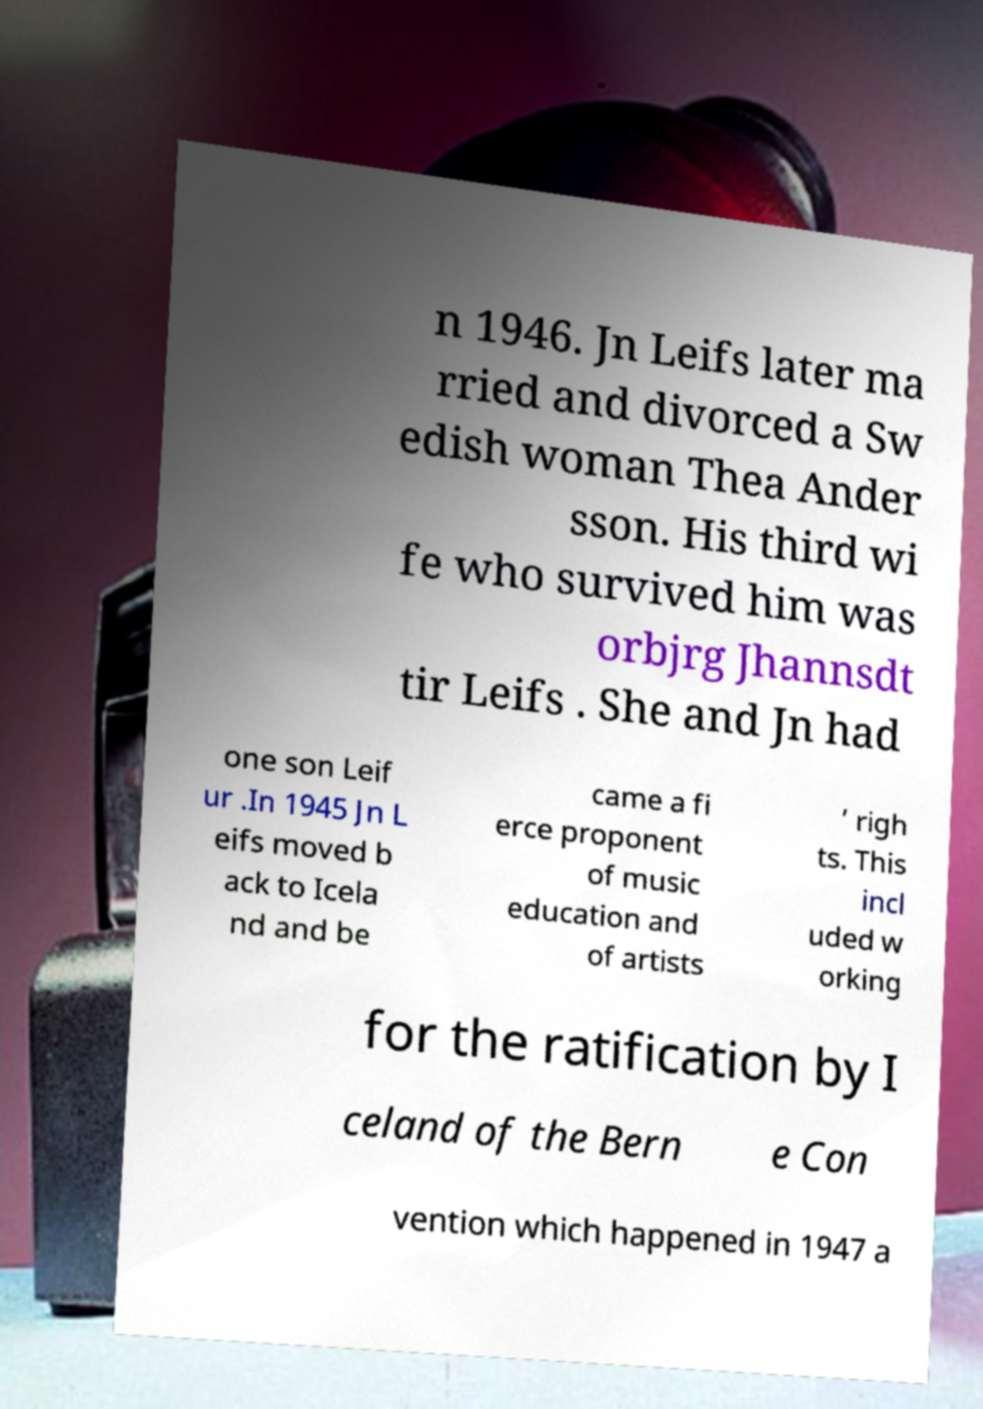There's text embedded in this image that I need extracted. Can you transcribe it verbatim? n 1946. Jn Leifs later ma rried and divorced a Sw edish woman Thea Ander sson. His third wi fe who survived him was orbjrg Jhannsdt tir Leifs . She and Jn had one son Leif ur .In 1945 Jn L eifs moved b ack to Icela nd and be came a fi erce proponent of music education and of artists ’ righ ts. This incl uded w orking for the ratification by I celand of the Bern e Con vention which happened in 1947 a 